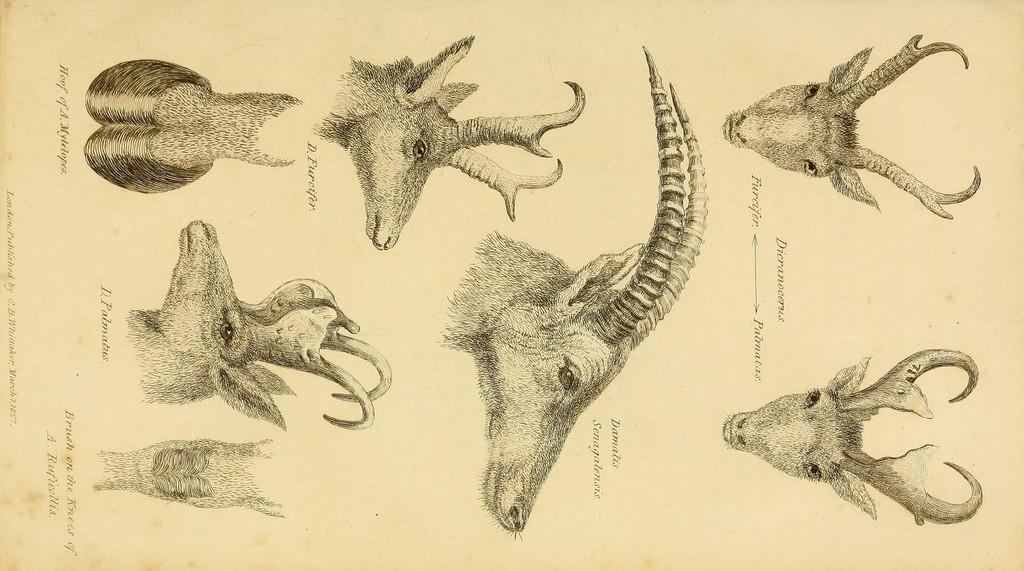Describe this image in one or two sentences. It is a poster. In this image there are depictions of animals and there is some text on the image. 